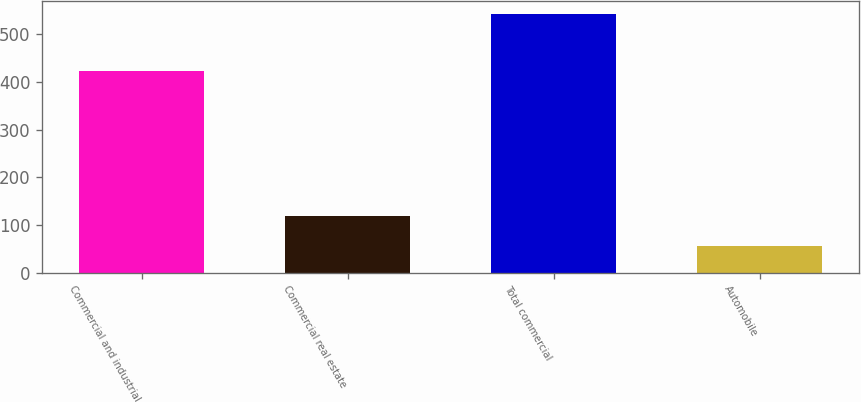Convert chart to OTSL. <chart><loc_0><loc_0><loc_500><loc_500><bar_chart><fcel>Commercial and industrial<fcel>Commercial real estate<fcel>Total commercial<fcel>Automobile<nl><fcel>422<fcel>120<fcel>542<fcel>56<nl></chart> 